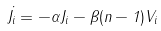<formula> <loc_0><loc_0><loc_500><loc_500>\dot { J _ { i } } = - \alpha J _ { i } - \beta ( n - 1 ) V _ { i }</formula> 